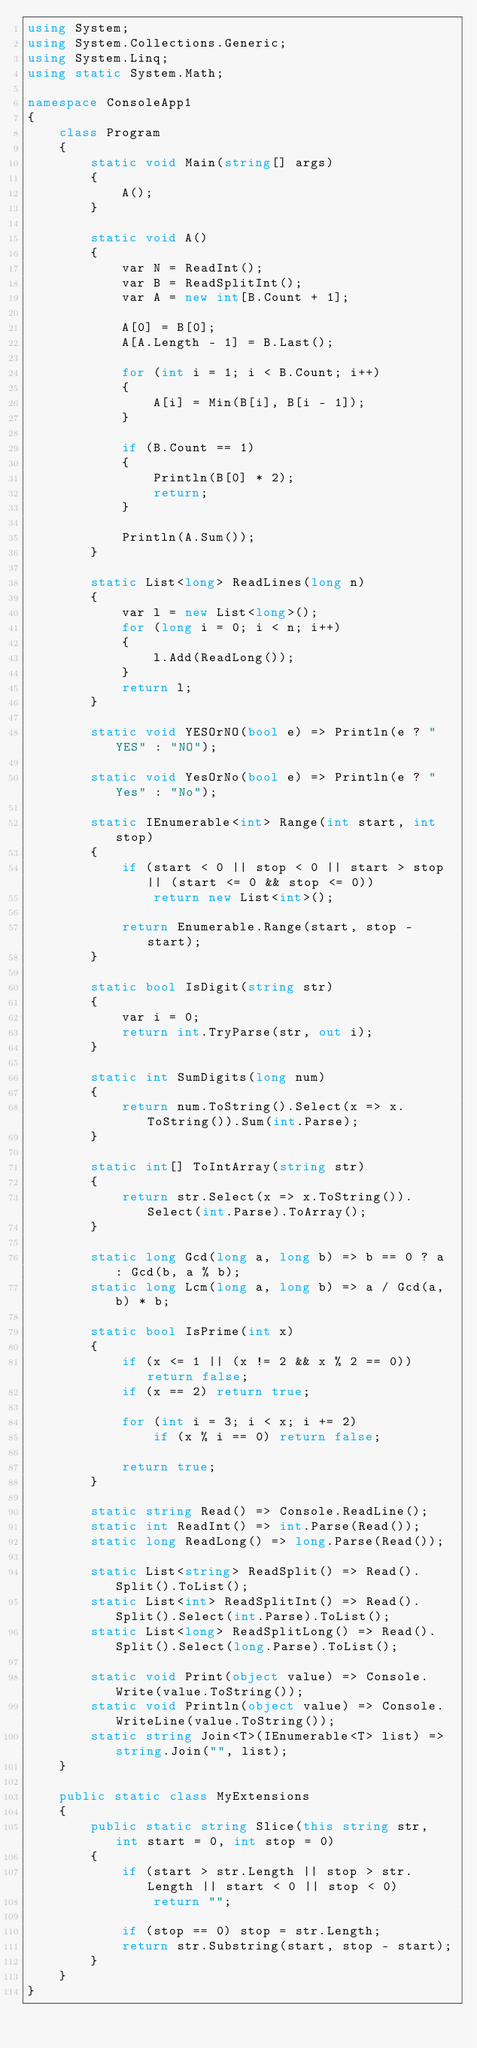<code> <loc_0><loc_0><loc_500><loc_500><_C#_>using System;
using System.Collections.Generic;
using System.Linq;
using static System.Math;

namespace ConsoleApp1
{
    class Program
    {
        static void Main(string[] args)
        {
            A();
        }

        static void A()
        {
            var N = ReadInt();
            var B = ReadSplitInt();
            var A = new int[B.Count + 1];

            A[0] = B[0];
            A[A.Length - 1] = B.Last();

            for (int i = 1; i < B.Count; i++)
            {
                A[i] = Min(B[i], B[i - 1]);
            }

            if (B.Count == 1)
            {
                Println(B[0] * 2);
                return;
            }

            Println(A.Sum());
        }

        static List<long> ReadLines(long n)
        {
            var l = new List<long>();
            for (long i = 0; i < n; i++)
            {
                l.Add(ReadLong());
            }
            return l;
        }

        static void YESOrNO(bool e) => Println(e ? "YES" : "NO");

        static void YesOrNo(bool e) => Println(e ? "Yes" : "No");

        static IEnumerable<int> Range(int start, int stop)
        {
            if (start < 0 || stop < 0 || start > stop || (start <= 0 && stop <= 0))
                return new List<int>();

            return Enumerable.Range(start, stop - start);
        }

        static bool IsDigit(string str)
        {
            var i = 0;
            return int.TryParse(str, out i);
        }

        static int SumDigits(long num)
        {
            return num.ToString().Select(x => x.ToString()).Sum(int.Parse);
        }

        static int[] ToIntArray(string str)
        {
            return str.Select(x => x.ToString()).Select(int.Parse).ToArray();
        }

        static long Gcd(long a, long b) => b == 0 ? a : Gcd(b, a % b);
        static long Lcm(long a, long b) => a / Gcd(a, b) * b;

        static bool IsPrime(int x)
        {
            if (x <= 1 || (x != 2 && x % 2 == 0)) return false;
            if (x == 2) return true;

            for (int i = 3; i < x; i += 2)
                if (x % i == 0) return false;

            return true;
        }

        static string Read() => Console.ReadLine();
        static int ReadInt() => int.Parse(Read());
        static long ReadLong() => long.Parse(Read());

        static List<string> ReadSplit() => Read().Split().ToList();
        static List<int> ReadSplitInt() => Read().Split().Select(int.Parse).ToList();
        static List<long> ReadSplitLong() => Read().Split().Select(long.Parse).ToList();

        static void Print(object value) => Console.Write(value.ToString());
        static void Println(object value) => Console.WriteLine(value.ToString());
        static string Join<T>(IEnumerable<T> list) => string.Join("", list);
    }

    public static class MyExtensions
    {
        public static string Slice(this string str, int start = 0, int stop = 0)
        {
            if (start > str.Length || stop > str.Length || start < 0 || stop < 0)
                return "";

            if (stop == 0) stop = str.Length;
            return str.Substring(start, stop - start);
        }
    }
}

</code> 